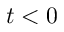<formula> <loc_0><loc_0><loc_500><loc_500>t < 0</formula> 